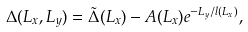<formula> <loc_0><loc_0><loc_500><loc_500>\Delta ( L _ { x } , L _ { y } ) = { \tilde { \Delta } } ( L _ { x } ) - A ( L _ { x } ) e ^ { - L _ { y } / l ( L _ { x } ) } ,</formula> 